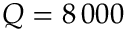<formula> <loc_0><loc_0><loc_500><loc_500>Q = 8 \, 0 0 0</formula> 